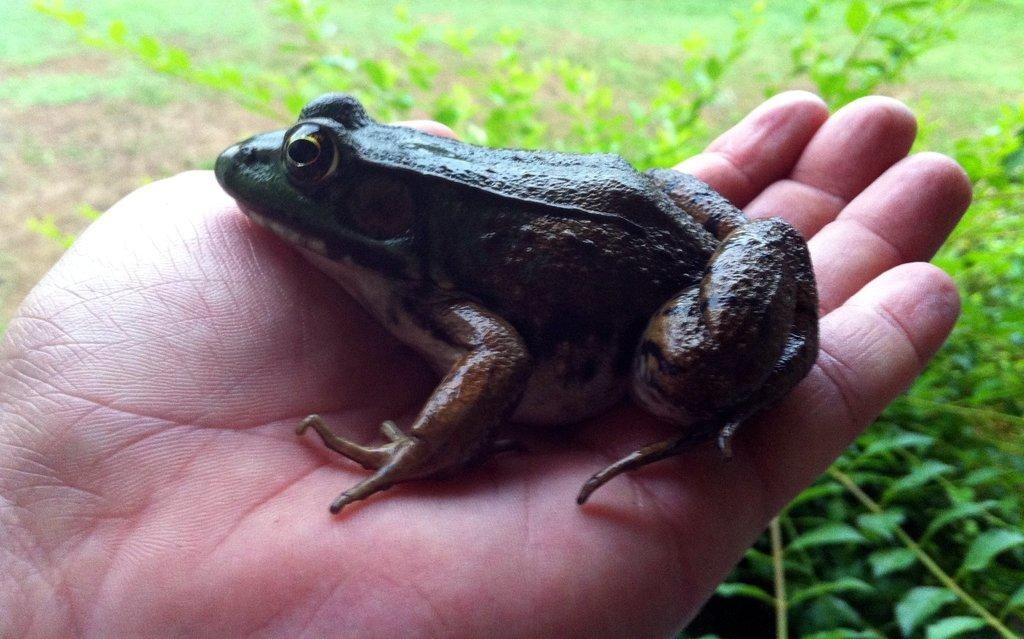What animal is present in the image? There is a frog in the image. How is the frog being held or supported in the image? The frog is being held by a person or is in a hand. What type of vegetation can be seen in the image? There are plants in the image. What decision is the frog making in the image? The image does not depict the frog making a decision, as it is a still image and not a representation of the frog's thought process. 